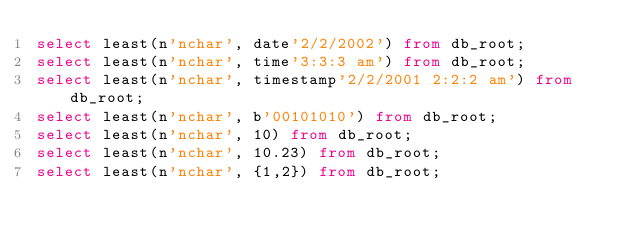<code> <loc_0><loc_0><loc_500><loc_500><_SQL_>select least(n'nchar', date'2/2/2002') from db_root;
select least(n'nchar', time'3:3:3 am') from db_root;
select least(n'nchar', timestamp'2/2/2001 2:2:2 am') from db_root;
select least(n'nchar', b'00101010') from db_root;
select least(n'nchar', 10) from db_root;
select least(n'nchar', 10.23) from db_root;
select least(n'nchar', {1,2}) from db_root;
</code> 